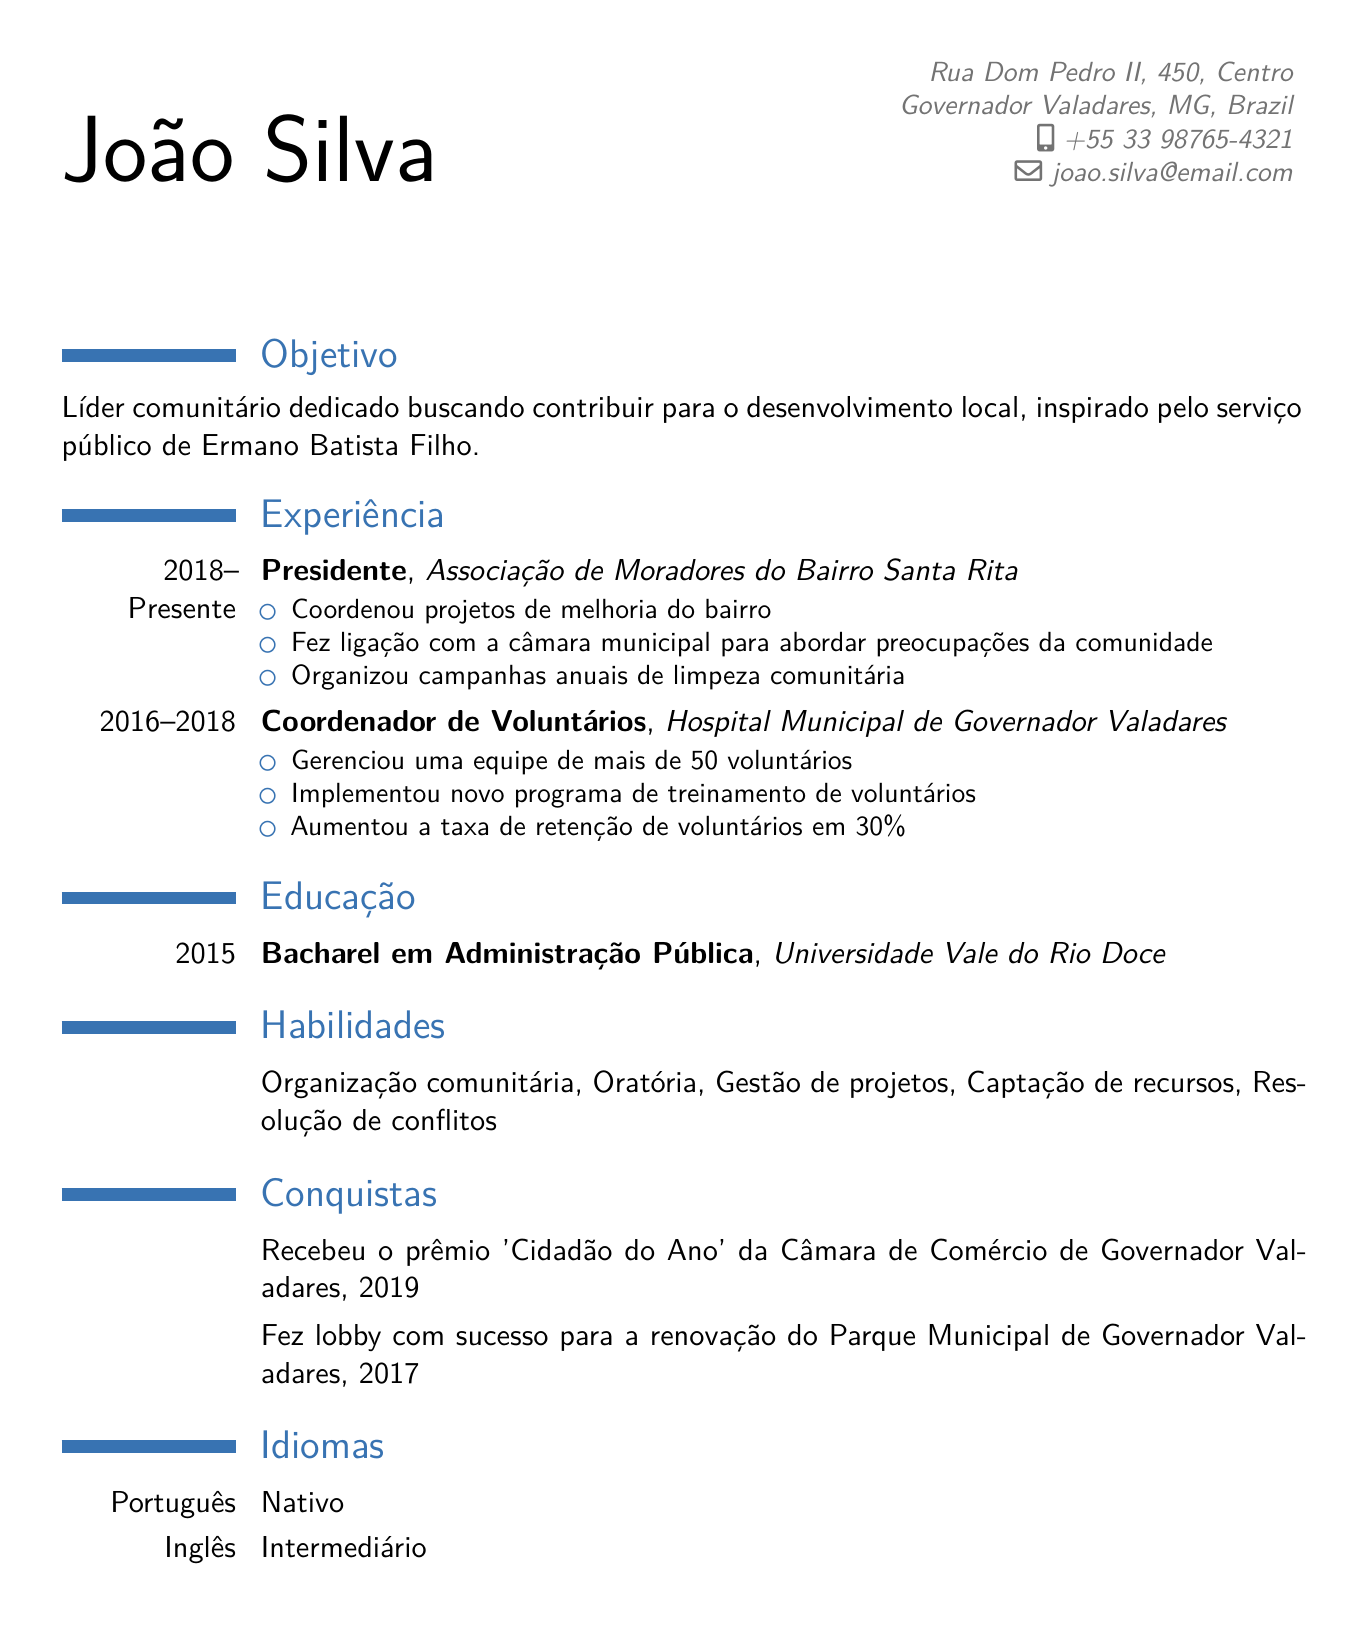what is the name of the individual on the resume? The name mentioned at the top of the resume is João Silva.
Answer: João Silva what is the duration of João's role as President? The role of President is listed as "2018 - Present," indicating he has been in this position since 2018.
Answer: 2018 - Present which organization did João volunteer with from 2016 to 2018? The organization where he served as Volunteer Coordinator during that time is the Hospital Municipal de Governador Valadares.
Answer: Hospital Municipal de Governador Valadares what award did João receive in 2019? The award he received in 2019 is 'Citizen of the Year' from the Governador Valadares Chamber of Commerce.
Answer: 'Citizen of the Year' how many volunteers did João manage as a Volunteer Coordinator? He managed a team of over 50 volunteers during his time as Volunteer Coordinator.
Answer: 50+ what is João's degree in? His degree is mentioned as a Bachelor’s in Public Administration.
Answer: Bachelor’s in Public Administration what annual event did João organize as President? He organized annual community clean-up drives as part of his responsibilities as President.
Answer: annual community clean-up drives which project did João successfully lobby for in 2017? He successfully lobbied for the renovation of Parque Municipal de Governador Valadares in 2017.
Answer: renovation of Parque Municipal de Governador Valadares 